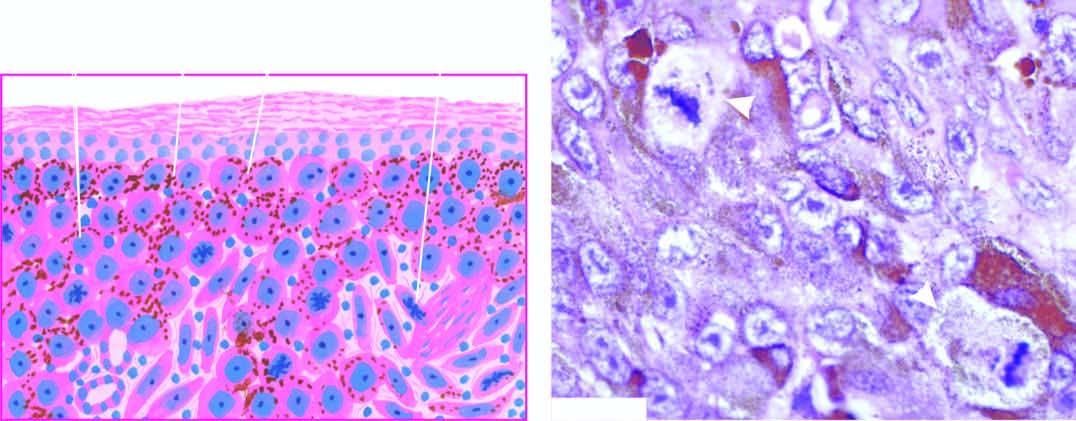do many of the tumour cells contain fine granular melanin pigment?
Answer the question using a single word or phrase. Yes 